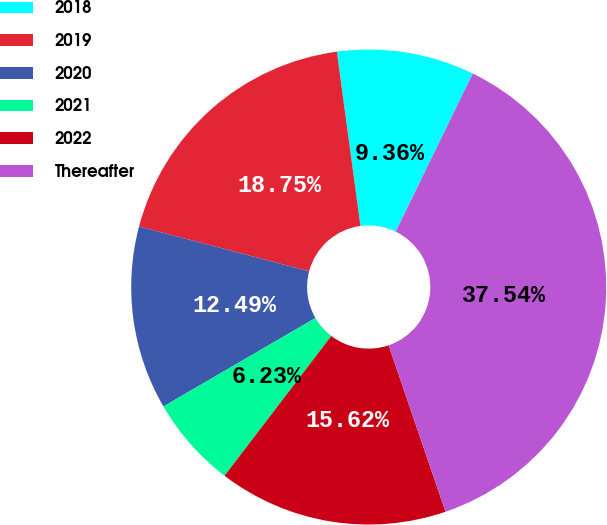<chart> <loc_0><loc_0><loc_500><loc_500><pie_chart><fcel>2018<fcel>2019<fcel>2020<fcel>2021<fcel>2022<fcel>Thereafter<nl><fcel>9.36%<fcel>18.75%<fcel>12.49%<fcel>6.23%<fcel>15.62%<fcel>37.53%<nl></chart> 